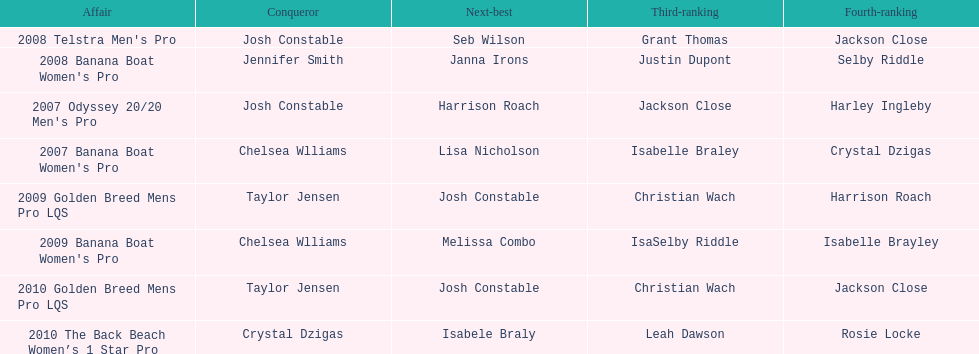Who was the top performer in the 2008 telstra men's pro? Josh Constable. Would you be able to parse every entry in this table? {'header': ['Affair', 'Conqueror', 'Next-best', 'Third-ranking', 'Fourth-ranking'], 'rows': [["2008 Telstra Men's Pro", 'Josh Constable', 'Seb Wilson', 'Grant Thomas', 'Jackson Close'], ["2008 Banana Boat Women's Pro", 'Jennifer Smith', 'Janna Irons', 'Justin Dupont', 'Selby Riddle'], ["2007 Odyssey 20/20 Men's Pro", 'Josh Constable', 'Harrison Roach', 'Jackson Close', 'Harley Ingleby'], ["2007 Banana Boat Women's Pro", 'Chelsea Wlliams', 'Lisa Nicholson', 'Isabelle Braley', 'Crystal Dzigas'], ['2009 Golden Breed Mens Pro LQS', 'Taylor Jensen', 'Josh Constable', 'Christian Wach', 'Harrison Roach'], ["2009 Banana Boat Women's Pro", 'Chelsea Wlliams', 'Melissa Combo', 'IsaSelby Riddle', 'Isabelle Brayley'], ['2010 Golden Breed Mens Pro LQS', 'Taylor Jensen', 'Josh Constable', 'Christian Wach', 'Jackson Close'], ['2010 The Back Beach Women’s 1 Star Pro', 'Crystal Dzigas', 'Isabele Braly', 'Leah Dawson', 'Rosie Locke']]} 